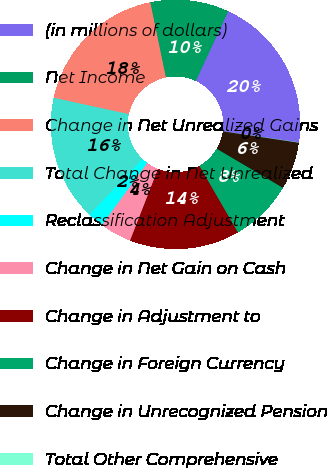Convert chart to OTSL. <chart><loc_0><loc_0><loc_500><loc_500><pie_chart><fcel>(in millions of dollars)<fcel>Net Income<fcel>Change in Net Unrealized Gains<fcel>Total Change in Net Unrealized<fcel>Reclassification Adjustment<fcel>Change in Net Gain on Cash<fcel>Change in Adjustment to<fcel>Change in Foreign Currency<fcel>Change in Unrecognized Pension<fcel>Total Other Comprehensive<nl><fcel>20.37%<fcel>10.2%<fcel>18.33%<fcel>16.3%<fcel>2.07%<fcel>4.11%<fcel>14.27%<fcel>8.17%<fcel>6.14%<fcel>0.04%<nl></chart> 